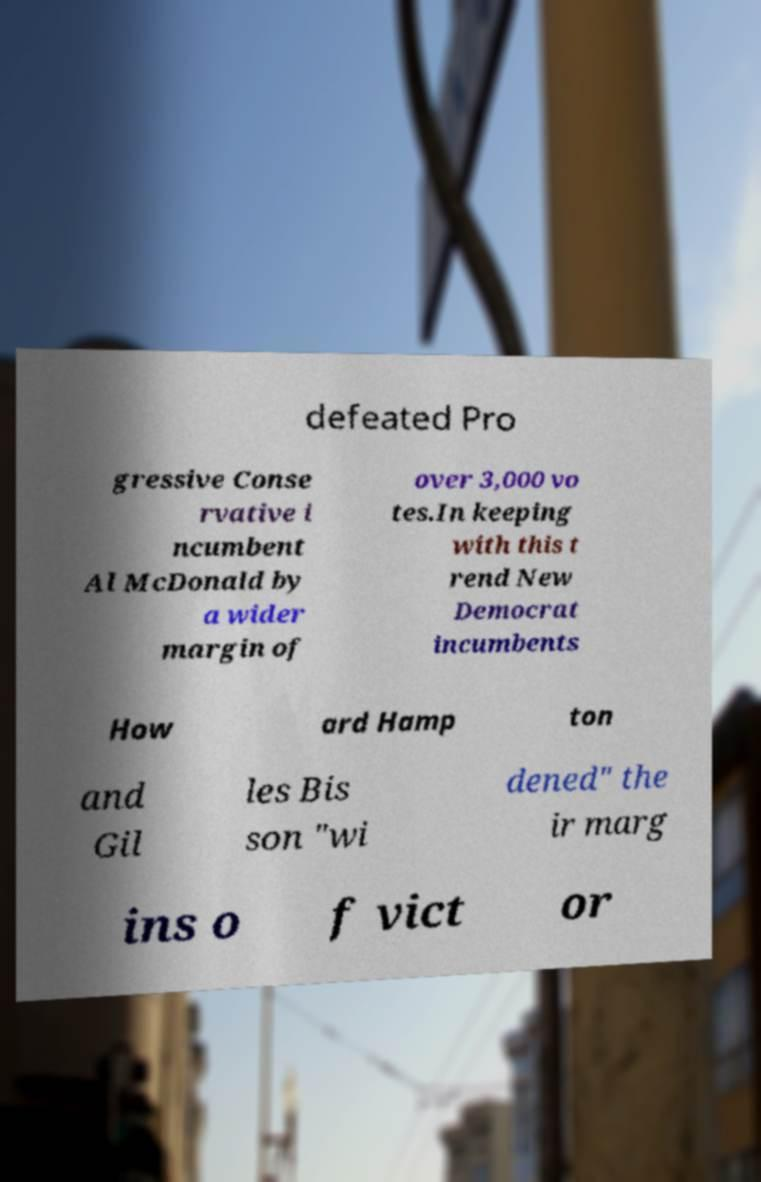Please identify and transcribe the text found in this image. defeated Pro gressive Conse rvative i ncumbent Al McDonald by a wider margin of over 3,000 vo tes.In keeping with this t rend New Democrat incumbents How ard Hamp ton and Gil les Bis son "wi dened" the ir marg ins o f vict or 